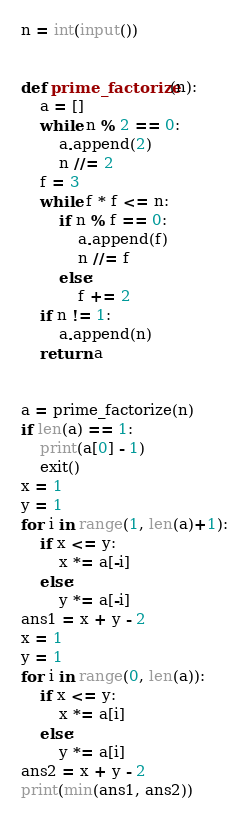Convert code to text. <code><loc_0><loc_0><loc_500><loc_500><_Python_>n = int(input())


def prime_factorize(n):
    a = []
    while n % 2 == 0:
        a.append(2)
        n //= 2
    f = 3
    while f * f <= n:
        if n % f == 0:
            a.append(f)
            n //= f
        else:
            f += 2
    if n != 1:
        a.append(n)
    return a


a = prime_factorize(n)
if len(a) == 1:
    print(a[0] - 1)
    exit()
x = 1
y = 1
for i in range(1, len(a)+1):
    if x <= y:
        x *= a[-i]
    else:
        y *= a[-i]
ans1 = x + y - 2
x = 1
y = 1
for i in range(0, len(a)):
    if x <= y:
        x *= a[i]
    else:
        y *= a[i]
ans2 = x + y - 2
print(min(ans1, ans2))
</code> 